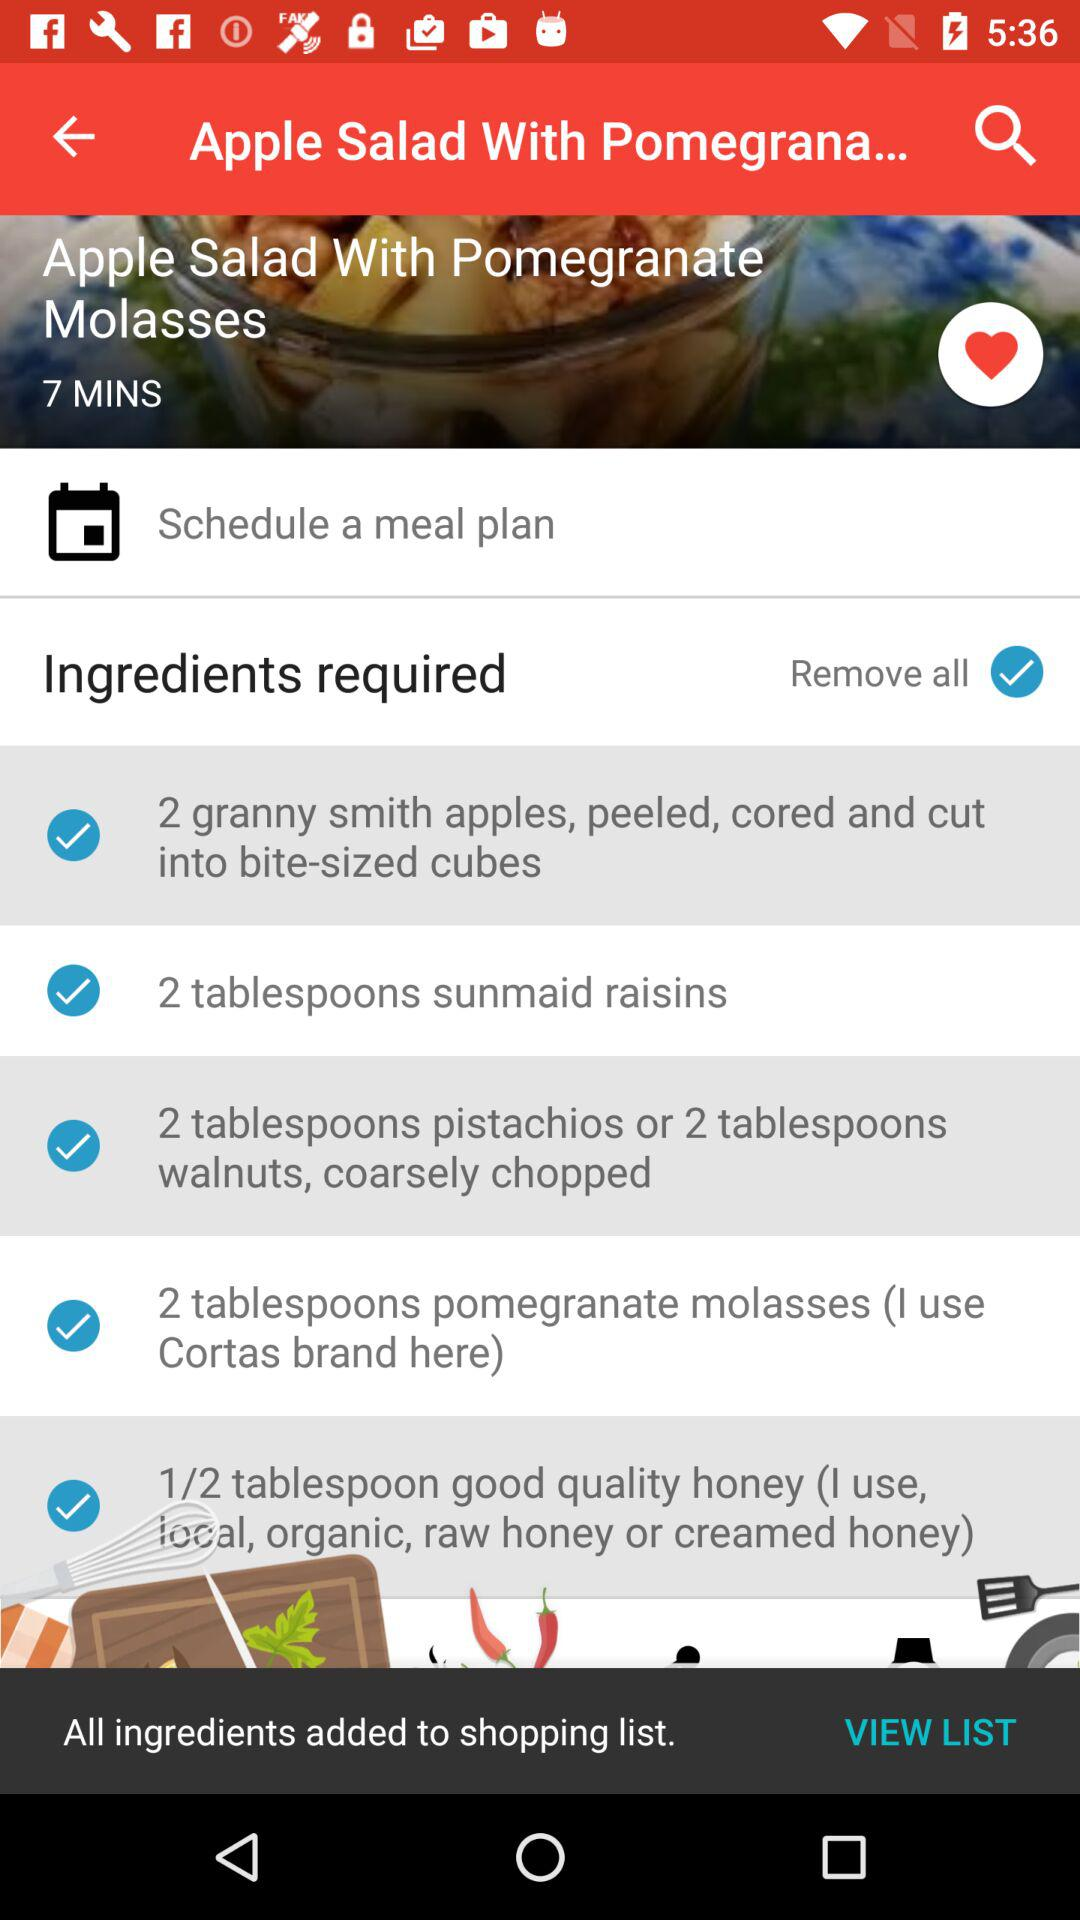What is the list of ingredients required to make "Apple Salad With Pomegranate Molasses"? The required list of ingredients is "2 granny smith apples, peeled, cored and cut into bite-sized cubes", "2 tablespoons sunmaid raisins", "2 tablespoons pistachios or 2 tablespoons walnuts, coarsely chopped", "2 tablespoons pomegranate molasses" and "1/2 tablespoon good quality honey". 